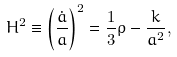<formula> <loc_0><loc_0><loc_500><loc_500>H ^ { 2 } \equiv \left ( \frac { \dot { a } } { a } \right ) ^ { 2 } = \frac { 1 } { 3 } \rho - \frac { k } { a ^ { 2 } } ,</formula> 